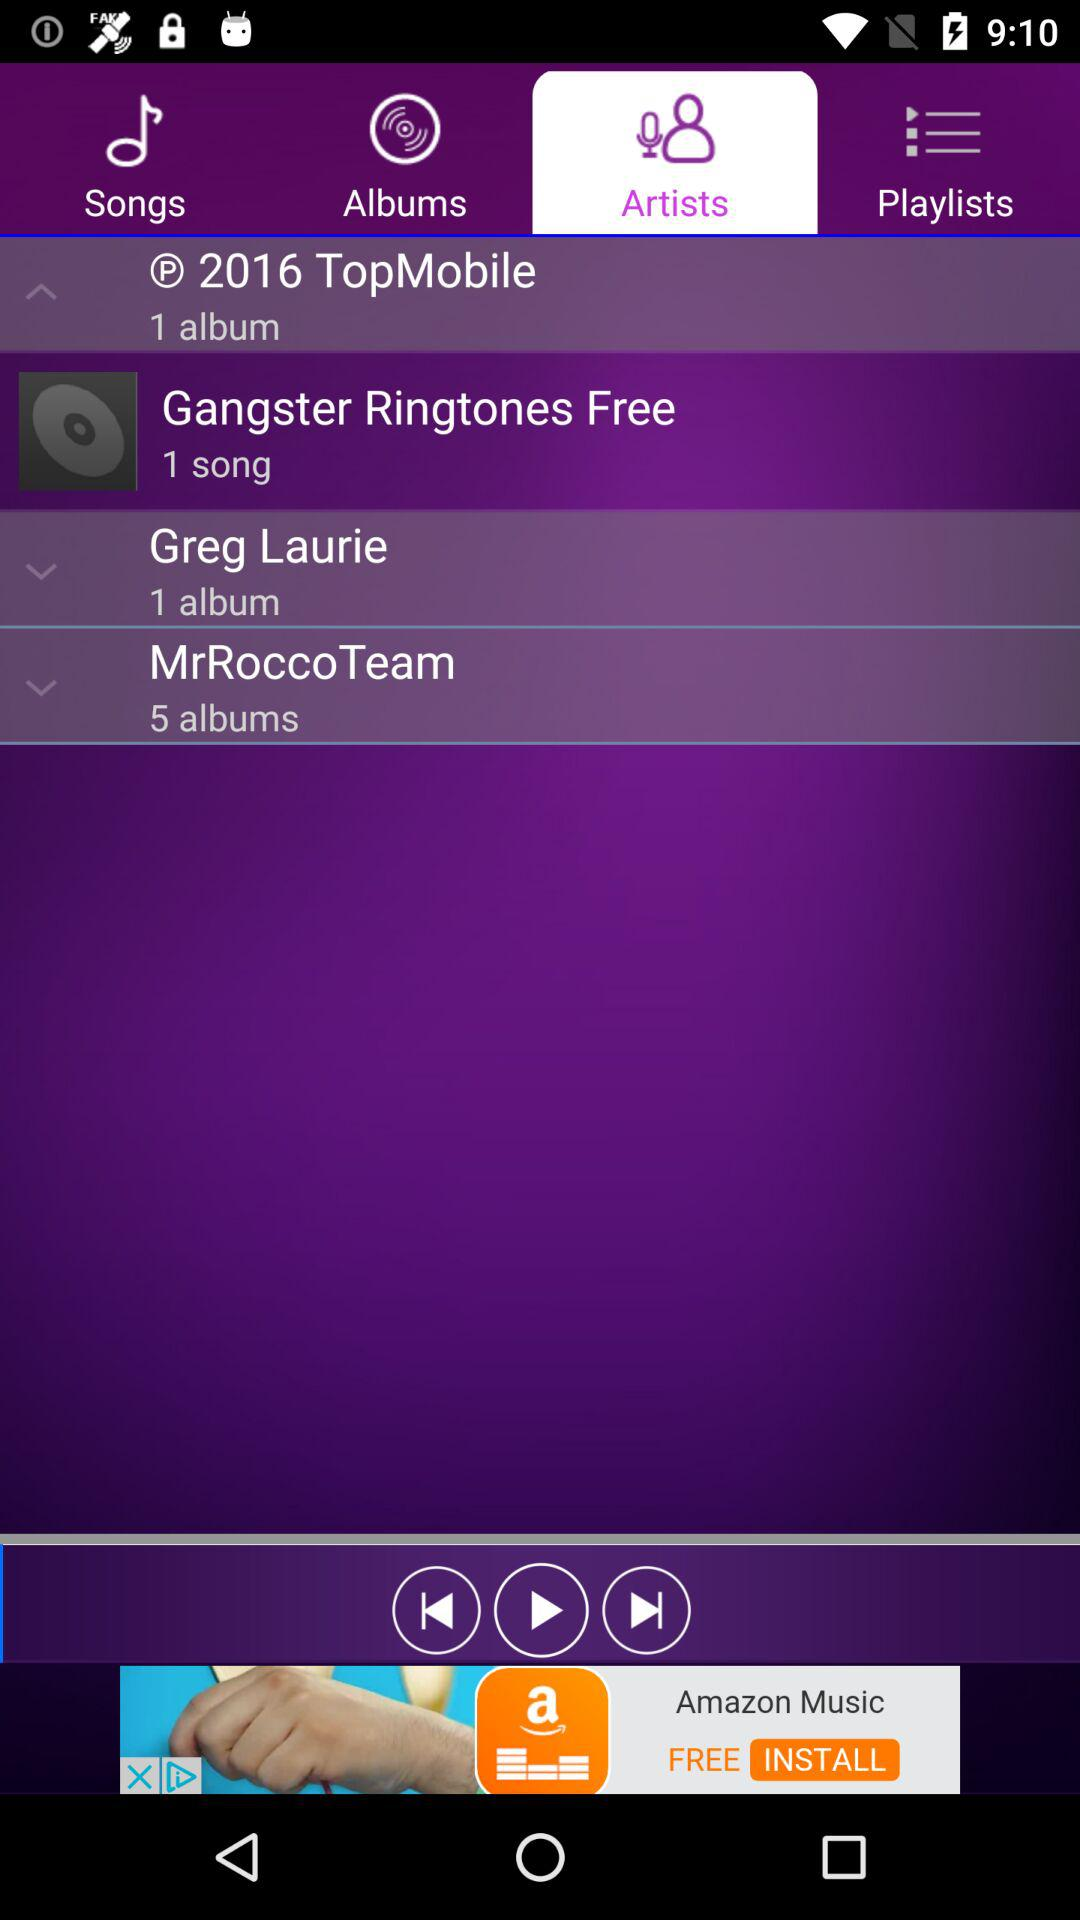How many albums are there in the "MrRoccoTeam"? There are 5 albums in the "MrRoccoTeam". 